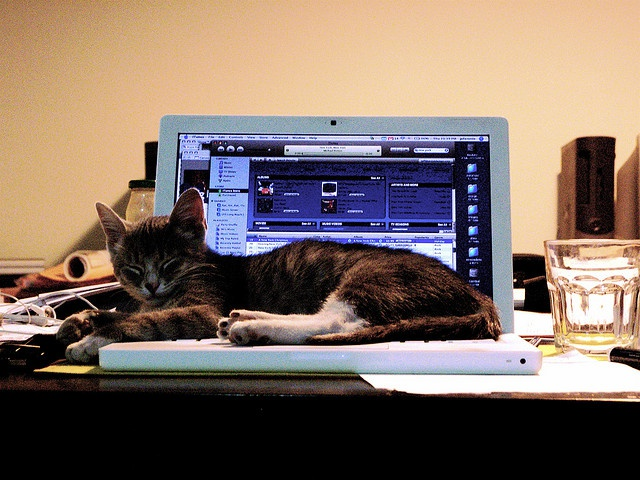Describe the objects in this image and their specific colors. I can see laptop in olive, black, darkgray, and lavender tones, cat in olive, black, maroon, and gray tones, cup in olive, white, and tan tones, and bottle in olive, tan, black, and salmon tones in this image. 